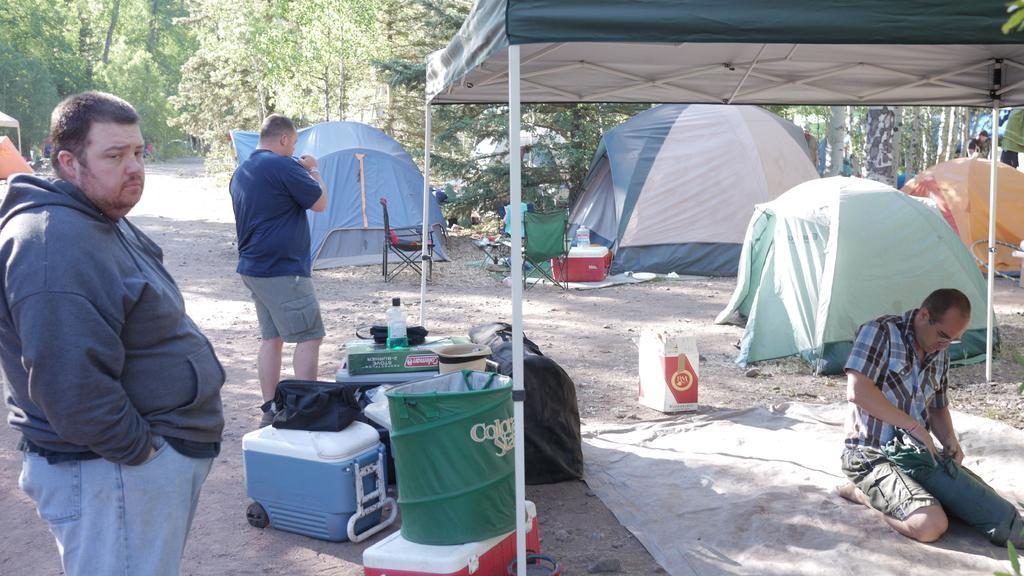Could you give a brief overview of what you see in this image? In this image, I can see two people standing and a person sitting on his knees. These are the tents. I can see the bags, baskets and few other things. These are the chairs. I can see the trees. This looks like a pathway. I think this is a mat. It looks like a cardboard box. 